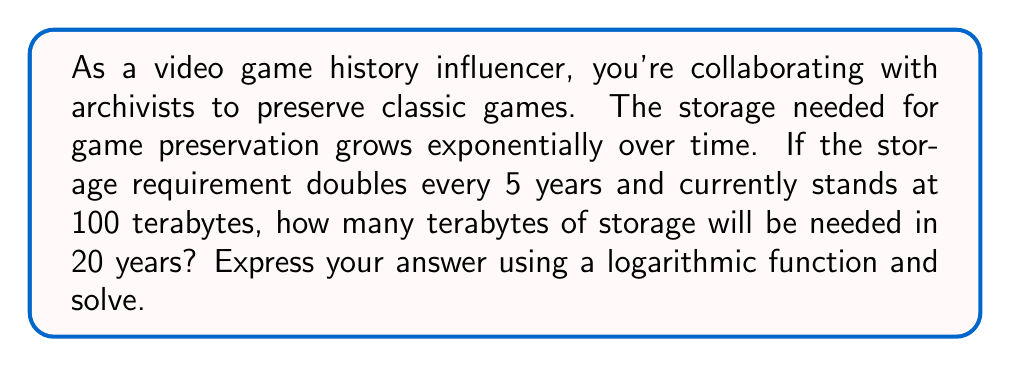Teach me how to tackle this problem. Let's approach this step-by-step:

1) First, we need to identify the key components of our exponential growth function:
   - Initial value: $a = 100$ terabytes
   - Time: $t = 20$ years
   - Doubling time: 5 years

2) The general form of an exponential growth function is:
   $$ f(t) = a \cdot b^t $$
   where $a$ is the initial value, $b$ is the growth factor, and $t$ is time.

3) To find $b$, we use the doubling time. In 5 years, the value doubles, so:
   $$ 2 = b^5 $$
   $$ b = 2^{\frac{1}{5}} $$

4) Now our function looks like:
   $$ f(t) = 100 \cdot (2^{\frac{1}{5}})^t $$

5) Simplify the exponent:
   $$ f(t) = 100 \cdot 2^{\frac{t}{5}} $$

6) Now, let's solve for $t = 20$:
   $$ f(20) = 100 \cdot 2^{\frac{20}{5}} = 100 \cdot 2^4 = 100 \cdot 16 = 1600 $$

7) To express this using a logarithmic function, we can use the property:
   $$ \log_2(2^x) = x $$

8) So, we can write:
   $$ 1600 = 100 \cdot 2^{\log_2(16)} $$
Answer: The storage needed in 20 years will be 1600 terabytes, which can be expressed as:
$$ 100 \cdot 2^{\log_2(16)} \text{ terabytes} $$ 